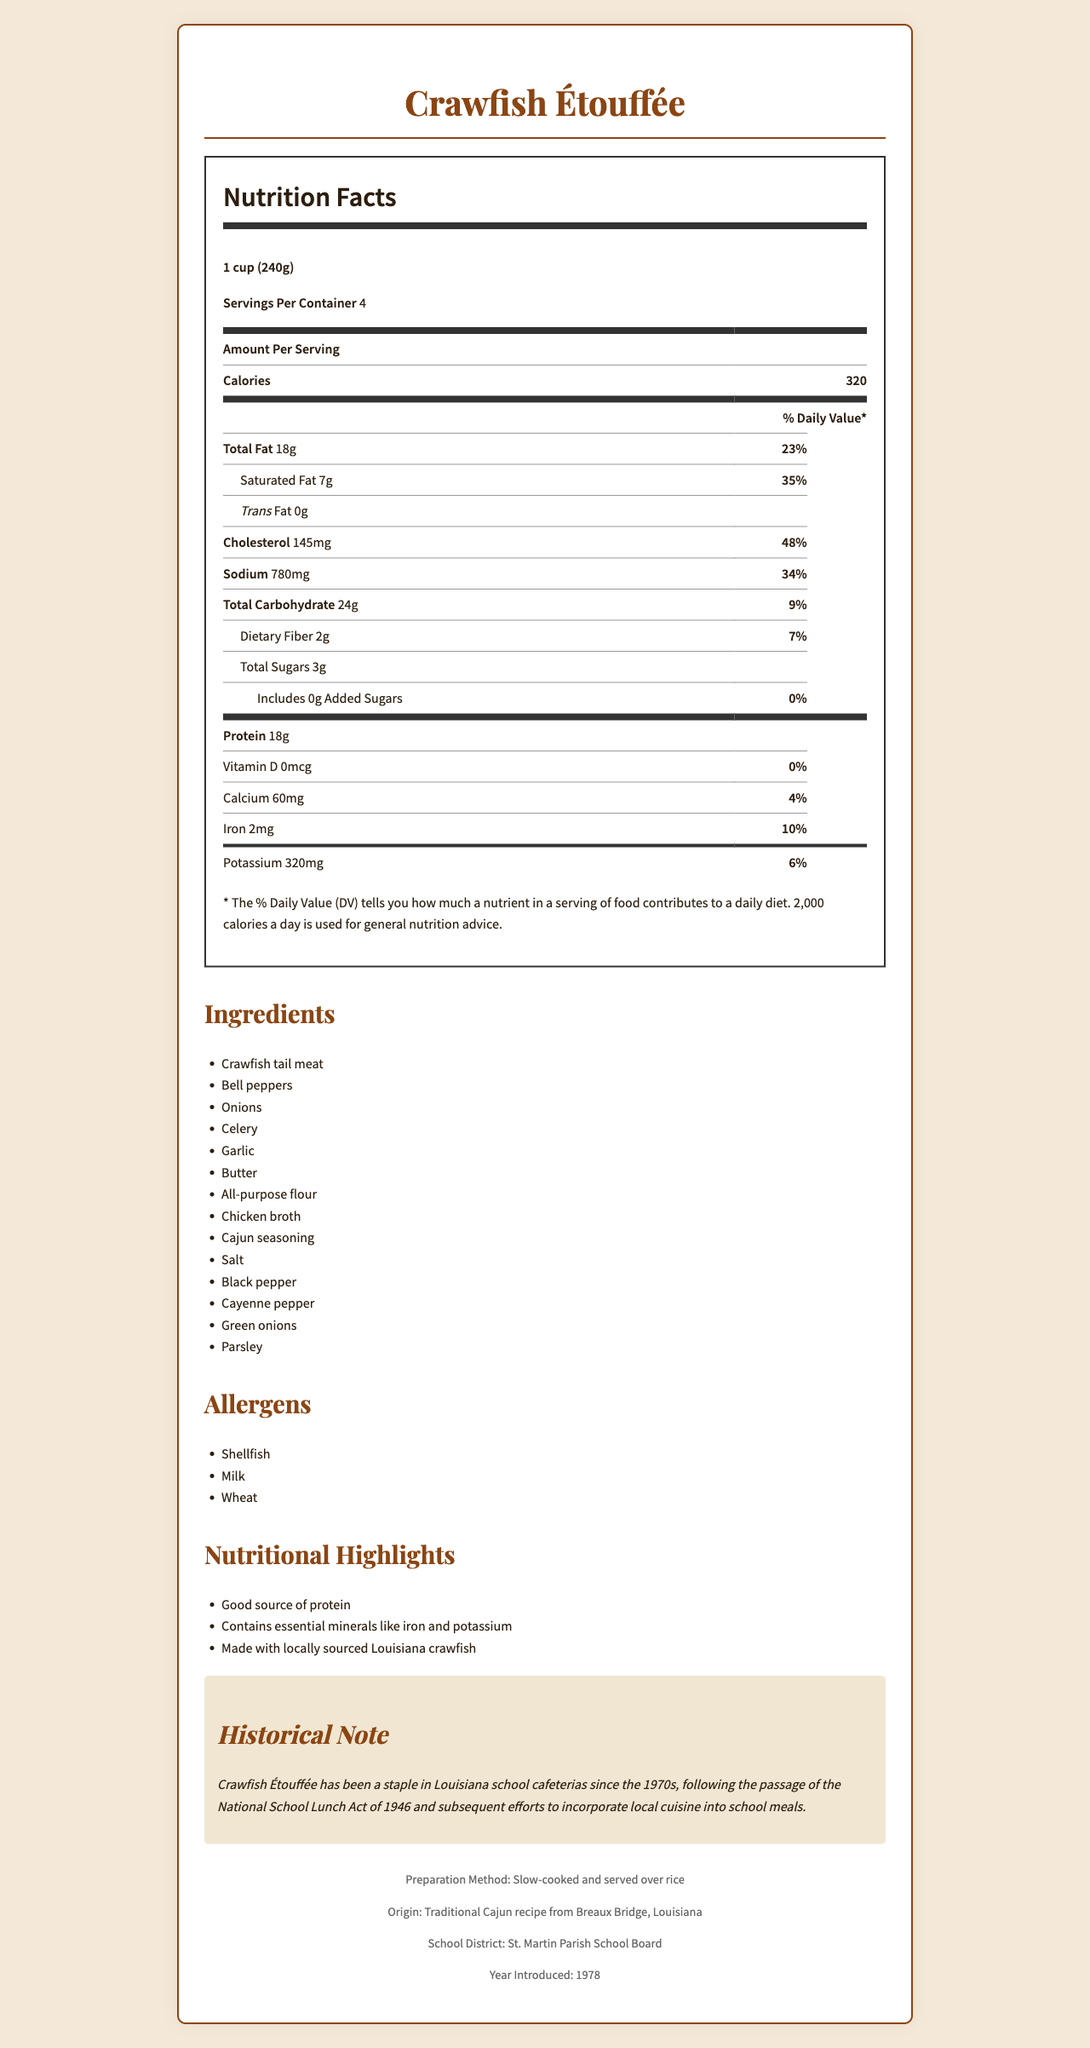what is the serving size for Crawfish Étouffée? The serving size is mentioned at the beginning of the Nutrition Facts section under the title of the document.
Answer: 1 cup (240g) how many calories per serving does Crawfish Étouffée contain? The amount of calories per serving is given in the Nutrition Facts table.
Answer: 320 how many servings per container are there? The number of servings per container is listed just below the serving size in the Nutrition Facts section.
Answer: 4 what are the main ingredients in Crawfish Étouffée? The ingredients are listed in a separate section titled "Ingredients."
Answer: Crawfish tail meat, Bell peppers, Onions, Celery, Garlic, Butter, All-purpose flour, Chicken broth, Cajun seasoning, Salt, Black pepper, Cayenne pepper, Green onions, Parsley what allergens are present in Crawfish Étouffée? The allergens are listed in a separate section titled "Allergens."
Answer: Shellfish, Milk, Wheat what is the total fat content per serving? The total fat content per serving is listed in the Nutrition Facts section under the 'Total Fat' entry.
Answer: 18g which of the following nutrients has the highest daily value percentage in one serving? A. Sodium B. Cholesterol C. Saturated Fat D. Dietary Fiber Cholesterol has a daily value percentage of 48%, which is higher than Sodium (34%), Saturated Fat (35%), and Dietary Fiber (7%).
Answer: B what is the percentage of daily value for saturated fat per serving? This information is listed in the Nutrition Facts section under 'Saturated Fat.'
Answer: 35% are there any added sugars in this dish? The Nutrition Facts section lists 0g added sugars.
Answer: No which essential minerals are highlighted in the nutritional highlights? A. Iron B. Copper C. Potassium D. Magnesium The nutritional highlights mention that it contains essential minerals like iron and potassium.
Answer: A, C is the preparation method of Crawfish Étouffée mentioned? The preparation method is stated in the footer section where it says "Slow-cooked and served over rice."
Answer: Yes how is Crawfish Étouffée historically significant in Louisiana school cafeterias? The historical note mentions that Crawfish Étouffée has been a staple in Louisiana school cafeterias since the 1970s due to efforts to include local cuisine in school meals.
Answer: It has been a staple since the 1970s, due to efforts to incorporate local cuisine following the National School Lunch Act of 1946. describe the main idea of the document. The document aims to offer comprehensive insight into the nutritional profile, ingredients, allergens, preparation methods, and historical significance of Crawfish Étouffée served in Louisiana school cafeterias.
Answer: The document provides detailed nutrition facts, ingredients, allergens, and historical context about Crawfish Étouffée, a traditional Cajun dish served in Louisiana school cafeterias. It includes serving size, calories, fat content, cholesterol, sodium, and other nutritional information. Additionally, it mentions the preparation method, origin, school district, and year the dish was introduced. when did St. Martin Parish School Board introduce Crawfish Étouffée in school cafeterias? The footer section mentions that the year introduced by the St. Martin Parish School Board is 1978.
Answer: 1978 what is the total carbohydrate content in a serving? The total carbohydrates per serving are stated in the Nutrition Facts section under 'Total Carbohydrate.'
Answer: 24g how much cholesterol does a serving contain? The cholesterol content per serving is listed in the Nutrition Facts section.
Answer: 145mg what is the preparation method? A. Deep-fried B. Grilled C. Slow-cooked and served over rice D. Baked The preparation method is mentioned in the footer as "slow-cooked and served over rice."
Answer: C does the document mention the presence of vitamin C in Crawfish Étouffée? The document does not mention anything about vitamin C content.
Answer: Not enough information 